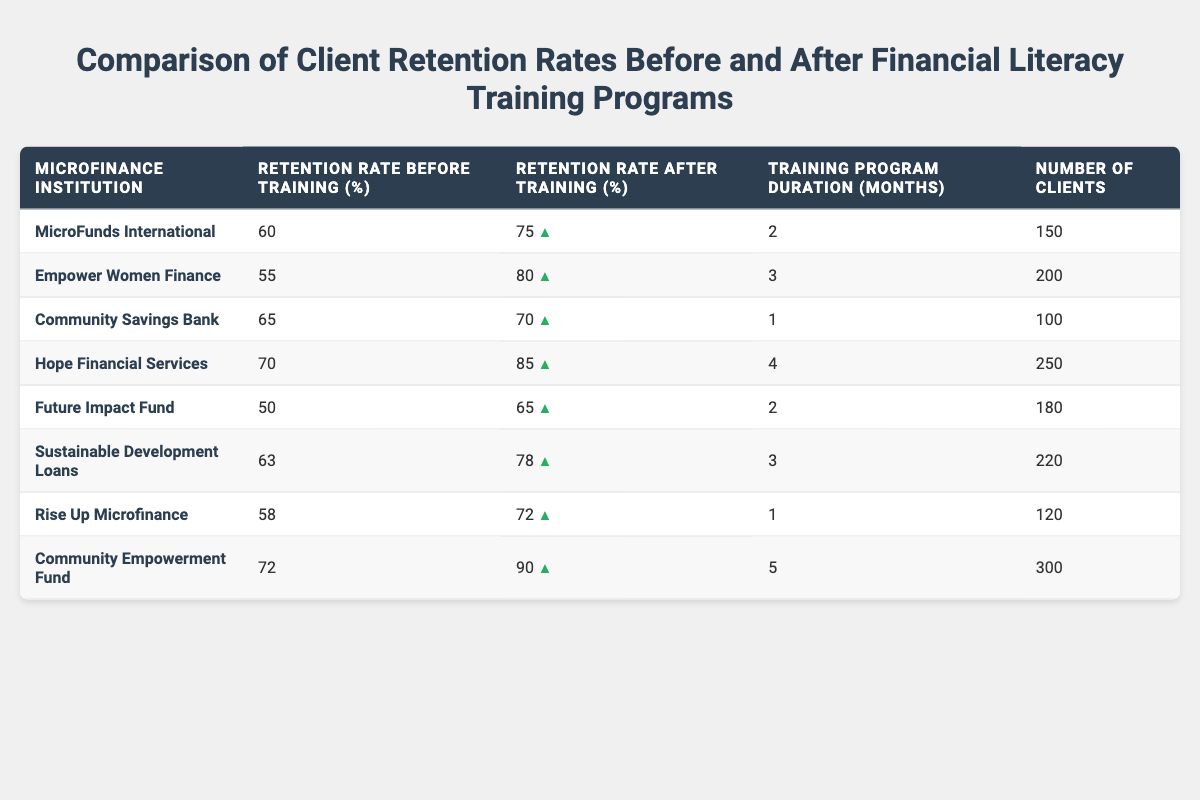What is the retention rate for 'Hope Financial Services' before the training? The table shows that 'Hope Financial Services' has a retention rate of 70% before the training program.
Answer: 70% What is the retention rate for 'Community Empowerment Fund' after the training? According to the table, 'Community Empowerment Fund' has a retention rate of 90% after the training program.
Answer: 90% Which microfinance institution had the longest training program duration? 'Community Empowerment Fund' had the longest training program duration of 5 months, as noted in the table.
Answer: 5 months What is the average retention rate before training across all institutions? Summing the retention rates before training (60, 55, 65, 70, 50, 63, 58, 72) gives  60 + 55 + 65 + 70 + 50 + 63 + 58 + 72 =  453. Dividing that by 8 (the number of institutions) results in an average of 56.625.
Answer: 56.625 Which institution showed the highest increase in retention rate after training? Comparing the increase in retention rates for each institution (15%, 25%, 5%, 15%, 15%, 15%, 14%, 18%), 'Empower Women Finance' showed the highest increase of 25%.
Answer: Empower Women Finance Did any institution show a decrease in retention rate after training? By examining the retention rates before and after training, no institution has a decrease; all increased their retention rates after training.
Answer: No How many clients did 'Sustainable Development Loans' serve? The table indicates 'Sustainable Development Loans' served 220 clients.
Answer: 220 What is the total number of clients served by all institutions combined? Adding all clients served by each institution (150 + 200 + 100 + 250 + 180 + 220 + 120 + 300) results in 1,520 clients altogether.
Answer: 1520 Which institution had the highest retention rate before training? The highest retention rate before training is found with 'Community Empowerment Fund' at 72%.
Answer: 72% What is the difference in retention rates before and after training for 'MicroFunds International'? The retention rates differ by subtracting the before training rate (60%) from the after training rate (75%), yielding a difference of 15%.
Answer: 15% 